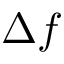Convert formula to latex. <formula><loc_0><loc_0><loc_500><loc_500>\Delta f</formula> 